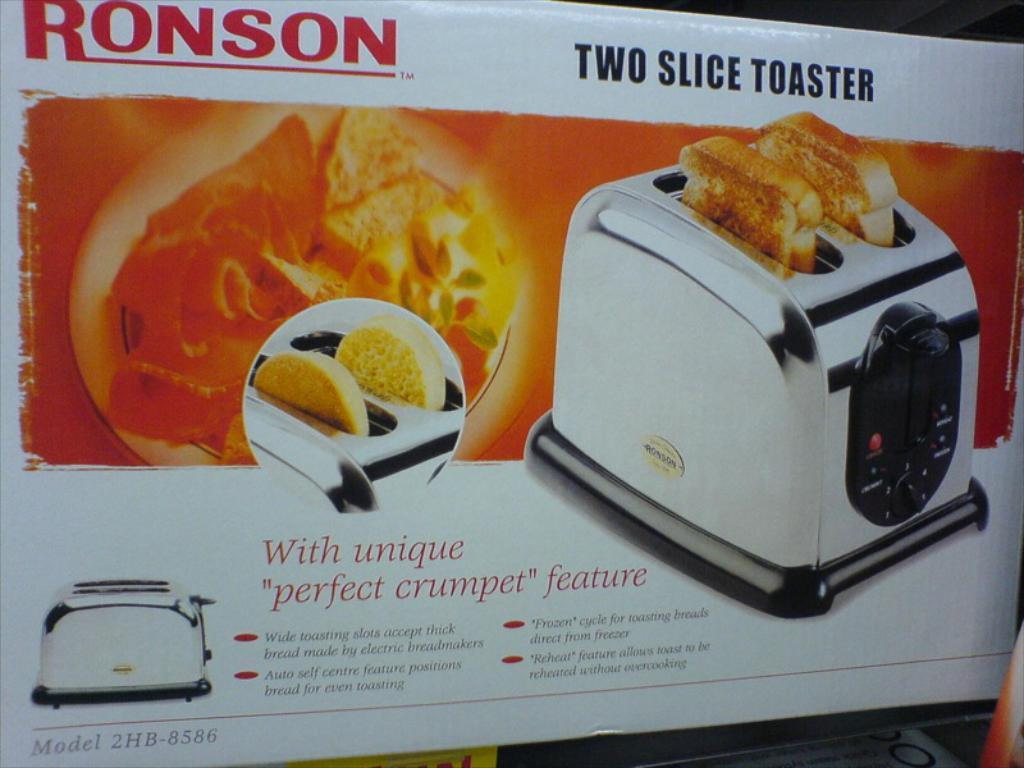<image>
Summarize the visual content of the image. A box containing a Ronson two slice toaster has an image of the product on the front. 